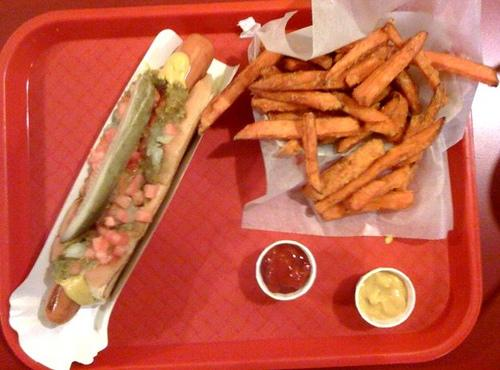What is on the left of the tray? Please explain your reasoning. hot dog. A hot dog is shown since it's a long sausage. 